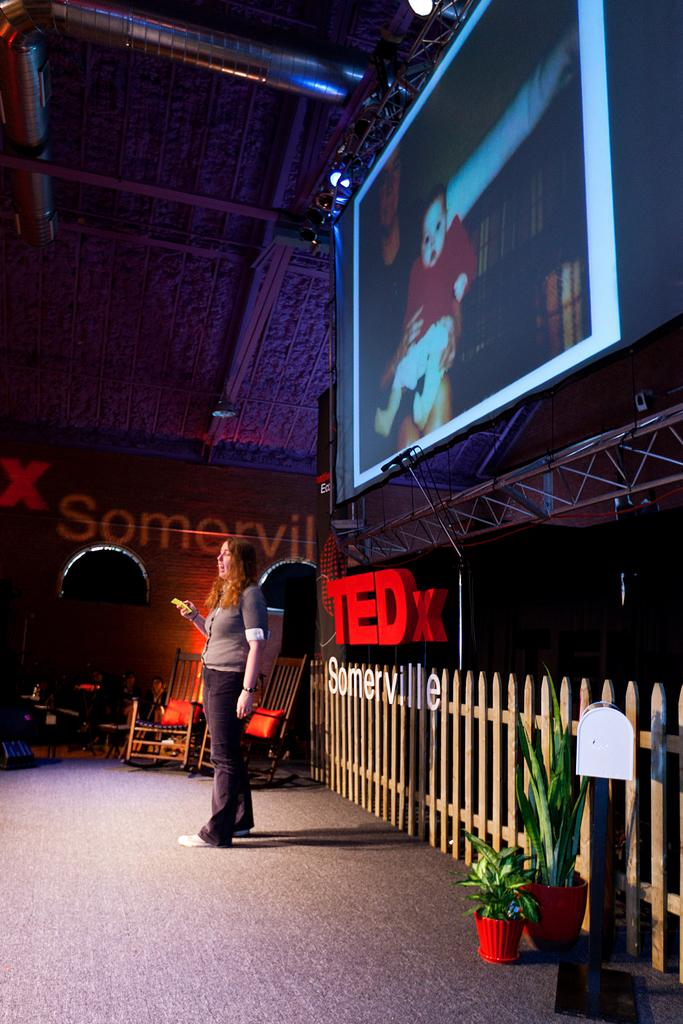What is the lady doing in the image? The lady is standing on the stage. What can be seen behind the lady on the stage? There is a fence behind the lady. What is hanging on the top of the stage? A TV is hanging on the top of the stage. Are there any plants visible on the stage? Yes, there are plant pots on the stage. What type of bottle is the lady holding in the image? There is no bottle present in the image; the lady is standing on the stage without holding anything. 